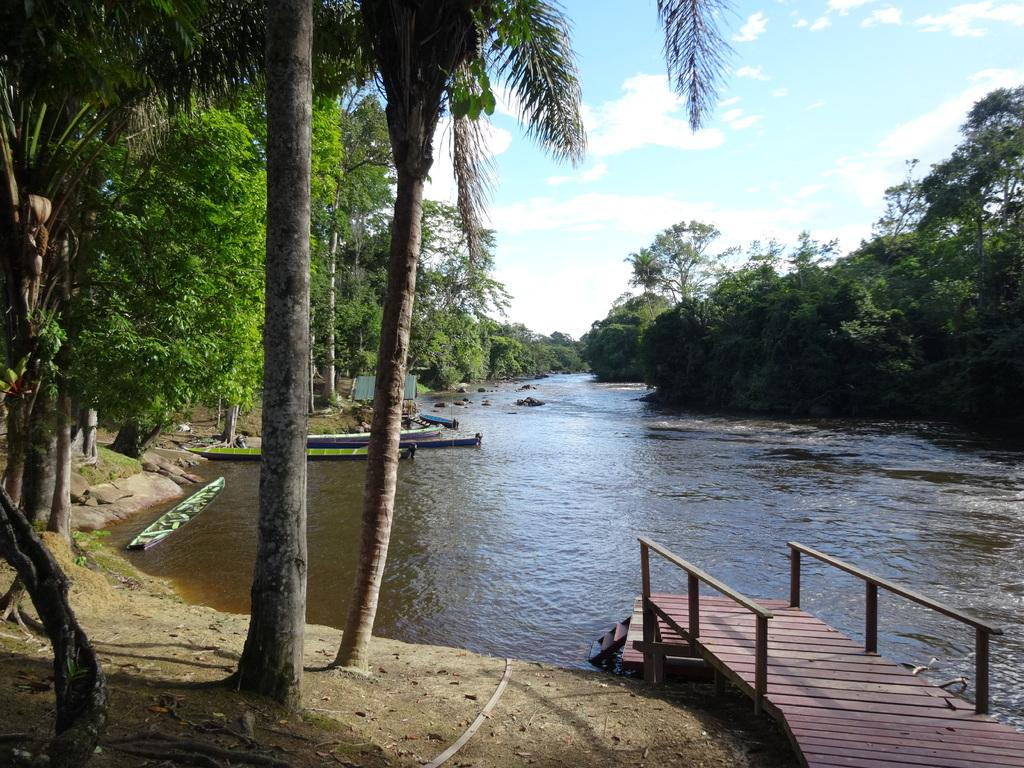What type of structure can be seen in the image? There is a bridge in the image. What type of terrain is visible in the image? There is land visible in the image. What type of vegetation is present in the image? Dried leaves and trees are present in the image. What type of watercraft can be seen in the image? Boats are on the surface of the river in the image. What part of the natural environment is visible in the image? The sky is visible in the image, and clouds are present in the sky. Where is the maid located in the image? There is no maid present in the image. What type of plant is the cactus in the image? There is no cactus present in the image. 